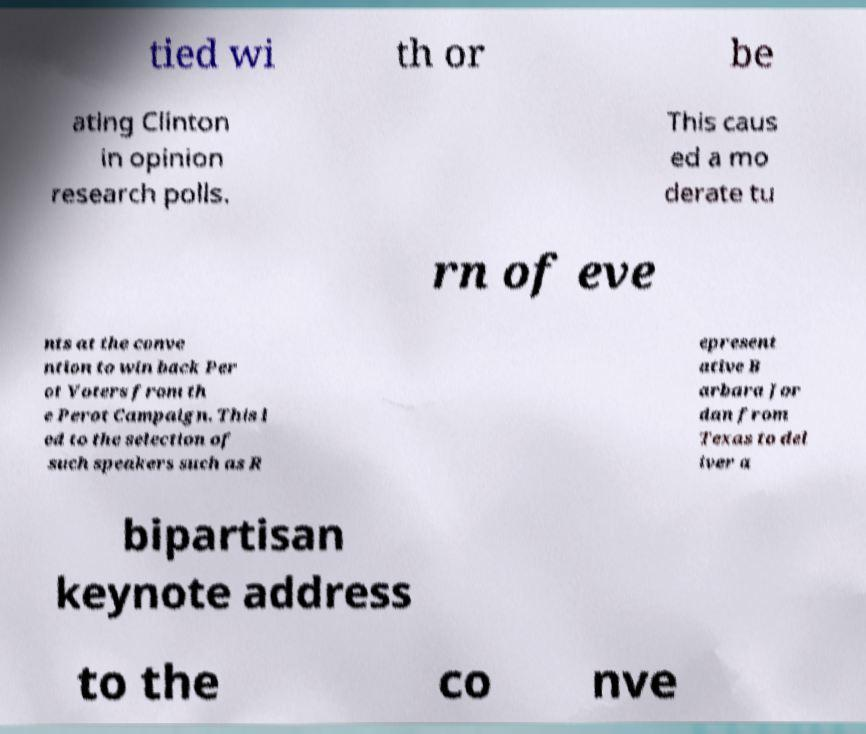Could you extract and type out the text from this image? tied wi th or be ating Clinton in opinion research polls. This caus ed a mo derate tu rn of eve nts at the conve ntion to win back Per ot Voters from th e Perot Campaign. This l ed to the selection of such speakers such as R epresent ative B arbara Jor dan from Texas to del iver a bipartisan keynote address to the co nve 